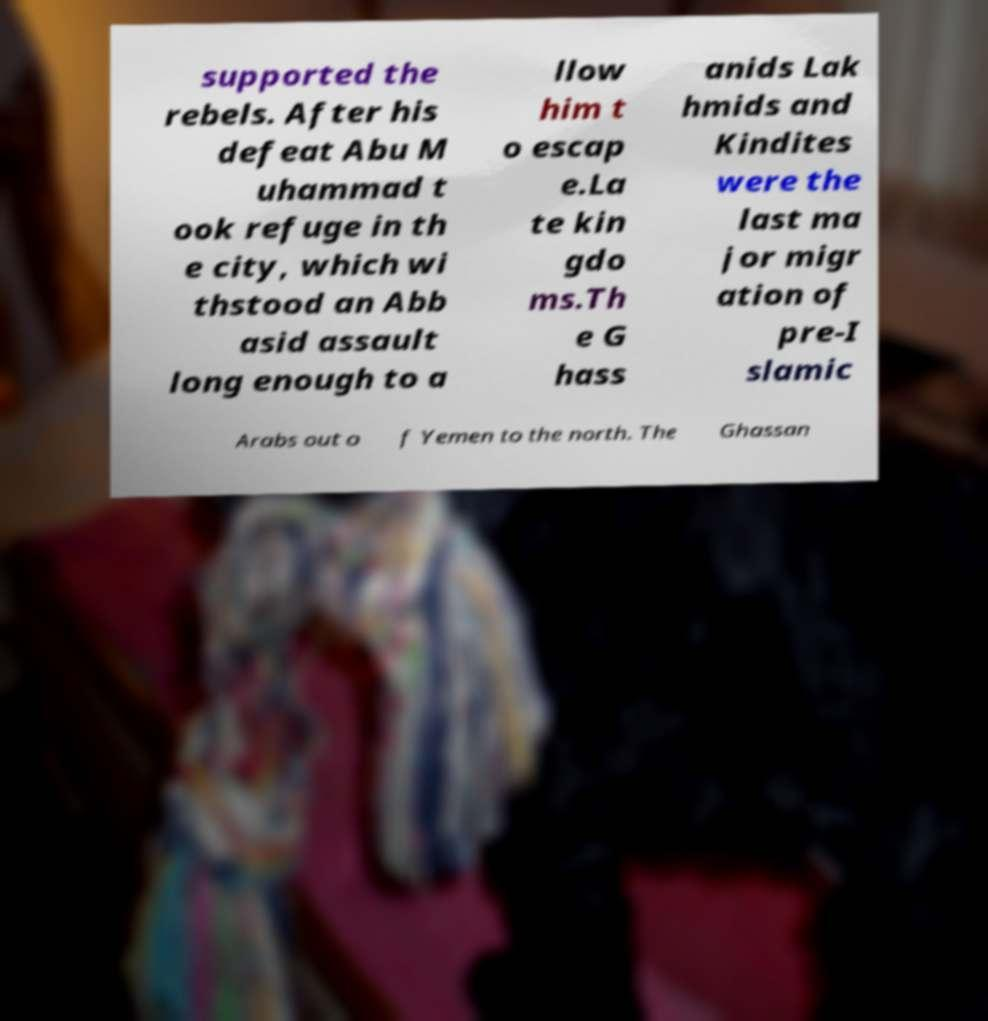Can you read and provide the text displayed in the image?This photo seems to have some interesting text. Can you extract and type it out for me? supported the rebels. After his defeat Abu M uhammad t ook refuge in th e city, which wi thstood an Abb asid assault long enough to a llow him t o escap e.La te kin gdo ms.Th e G hass anids Lak hmids and Kindites were the last ma jor migr ation of pre-I slamic Arabs out o f Yemen to the north. The Ghassan 